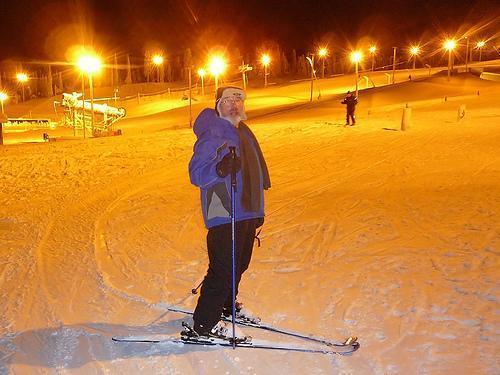How many people are in the picture?
Give a very brief answer. 2. 